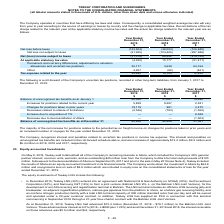According to Teekay Corporation's financial document, What was the Increases for positions related to the current year in 2019? According to the financial document, 5,829 (in thousands). The relevant text states: "creases for positions related to the current year 5,829 9,297 2,631..." Also, What are the increases for the interest and penalties on unrecognized tax benefits in 2019, 2018 and 2017 respectively? The document contains multiple relevant values: $13.2 million, $9.2 million, $6.4 million. From the document: "schedule above, and are increases of approximately $13.2 million, $9.2 million and $6.4 million in 2019, 2018 and 2017, respectively. s of approximate..." Also, What is included in the income tax expense? interest and penalties related to uncertain tax positions. The document states: "The Company recognizes interest and penalties related to uncertain tax positions in income tax expense. The interest and penalties on unrecognized tax..." Also, can you calculate: What is the change in Balance of unrecognized tax benefits as at January 1 between 2018 and 2019? Based on the calculation: 40,556-31,061, the result is 9495 (in thousands). This is based on the information: "unrecognized tax benefits as at January 1 40,556 31,061 19,492 ance of unrecognized tax benefits as at January 1 40,556 31,061 19,492..." The key data points involved are: 31,061, 40,556. Also, can you calculate: What is the change in Changes for positions taken in prior years from December 31, 2019 to December 31, 2018? Based on the calculation: 19,119-981, the result is 18138 (in thousands). This is based on the information: "Changes for positions taken in prior years 19,119 981 3,475 Changes for positions taken in prior years 19,119 981 3,475..." The key data points involved are: 19,119, 981. Additionally, Which year has the highest Balance of unrecognized tax benefits as at December 31? According to the financial document, 2019. The relevant text states: "2019..." 